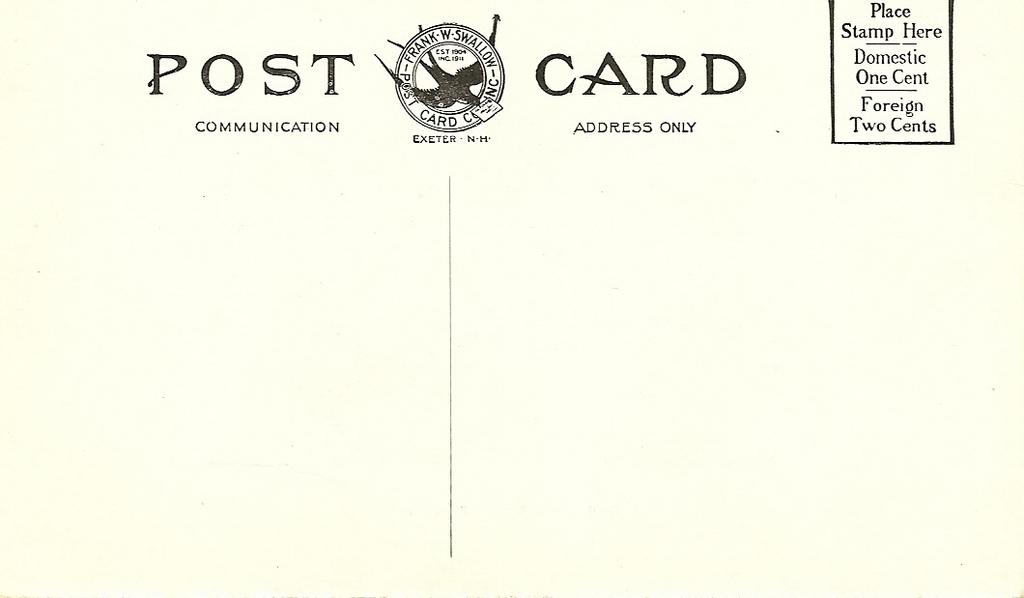How much would domestic shipping cost be?
Offer a very short reply. One cent. What type of card is this?
Your answer should be very brief. Post card. 